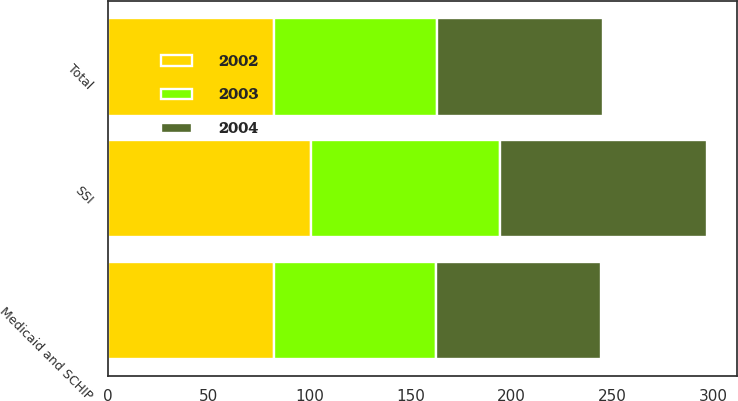Convert chart to OTSL. <chart><loc_0><loc_0><loc_500><loc_500><stacked_bar_chart><ecel><fcel>Medicaid and SCHIP<fcel>SSI<fcel>Total<nl><fcel>2003<fcel>80.4<fcel>93.8<fcel>80.7<nl><fcel>2004<fcel>81.7<fcel>102.5<fcel>82.4<nl><fcel>2002<fcel>82.2<fcel>100.7<fcel>82.3<nl></chart> 